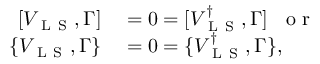Convert formula to latex. <formula><loc_0><loc_0><loc_500><loc_500>\begin{array} { r l } { [ V _ { L S } , \Gamma ] } & = 0 = [ V _ { L S } ^ { \dagger } , \Gamma ] \, o r } \\ { \{ V _ { L S } , \Gamma \} } & = 0 = \{ V _ { L S } ^ { \dagger } , \Gamma \} , } \end{array}</formula> 